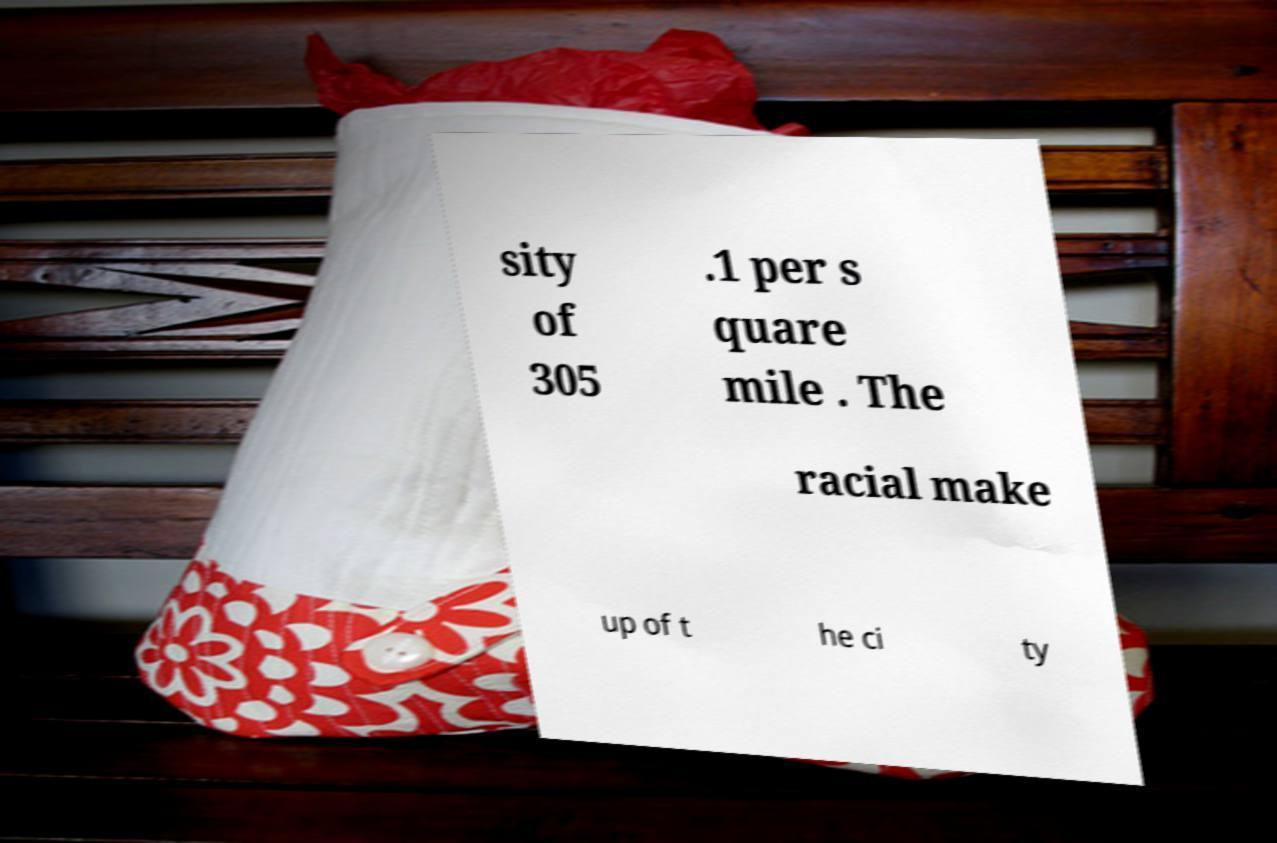Please read and relay the text visible in this image. What does it say? sity of 305 .1 per s quare mile . The racial make up of t he ci ty 